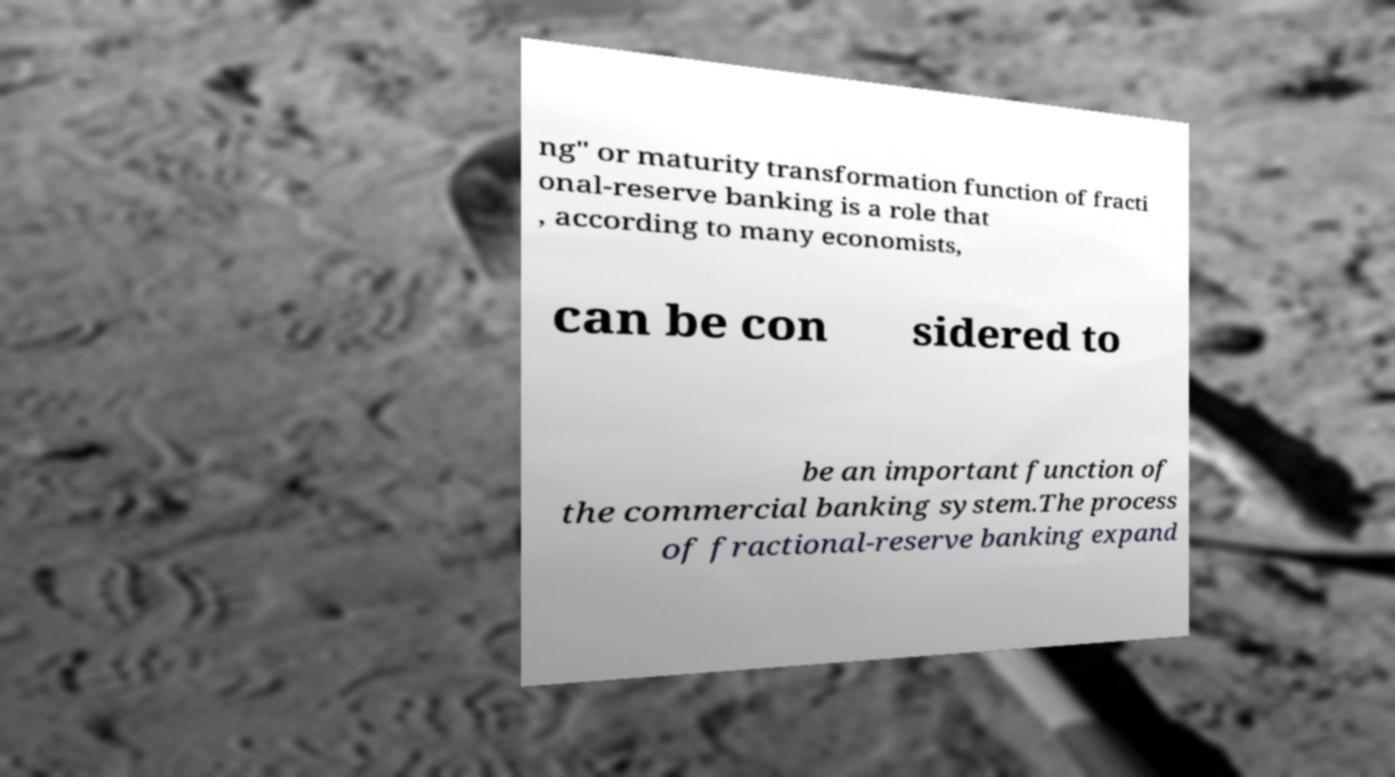Can you accurately transcribe the text from the provided image for me? ng" or maturity transformation function of fracti onal-reserve banking is a role that , according to many economists, can be con sidered to be an important function of the commercial banking system.The process of fractional-reserve banking expand 